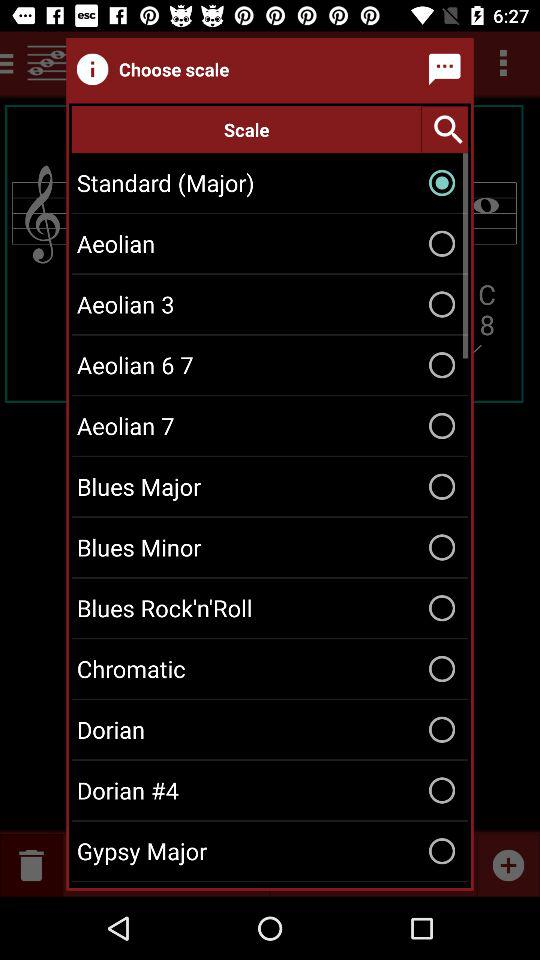Which "Scale" is selected? The selected "Scale" is "Standard (Major)". 